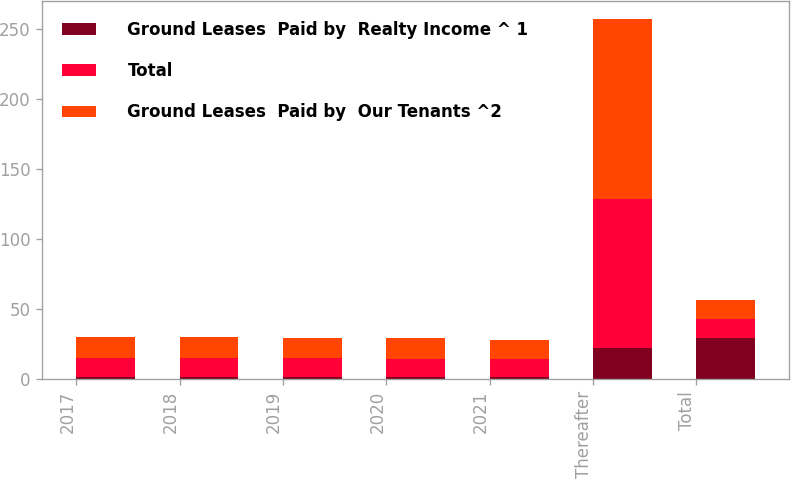Convert chart to OTSL. <chart><loc_0><loc_0><loc_500><loc_500><stacked_bar_chart><ecel><fcel>2017<fcel>2018<fcel>2019<fcel>2020<fcel>2021<fcel>Thereafter<fcel>Total<nl><fcel>Ground Leases  Paid by  Realty Income ^ 1<fcel>1.6<fcel>1.6<fcel>1.5<fcel>1.4<fcel>1.2<fcel>22.1<fcel>29.4<nl><fcel>Total<fcel>13.4<fcel>13.5<fcel>13.3<fcel>13.1<fcel>12.8<fcel>106.6<fcel>13.5<nl><fcel>Ground Leases  Paid by  Our Tenants ^2<fcel>15<fcel>15.1<fcel>14.8<fcel>14.5<fcel>14<fcel>128.7<fcel>13.5<nl></chart> 